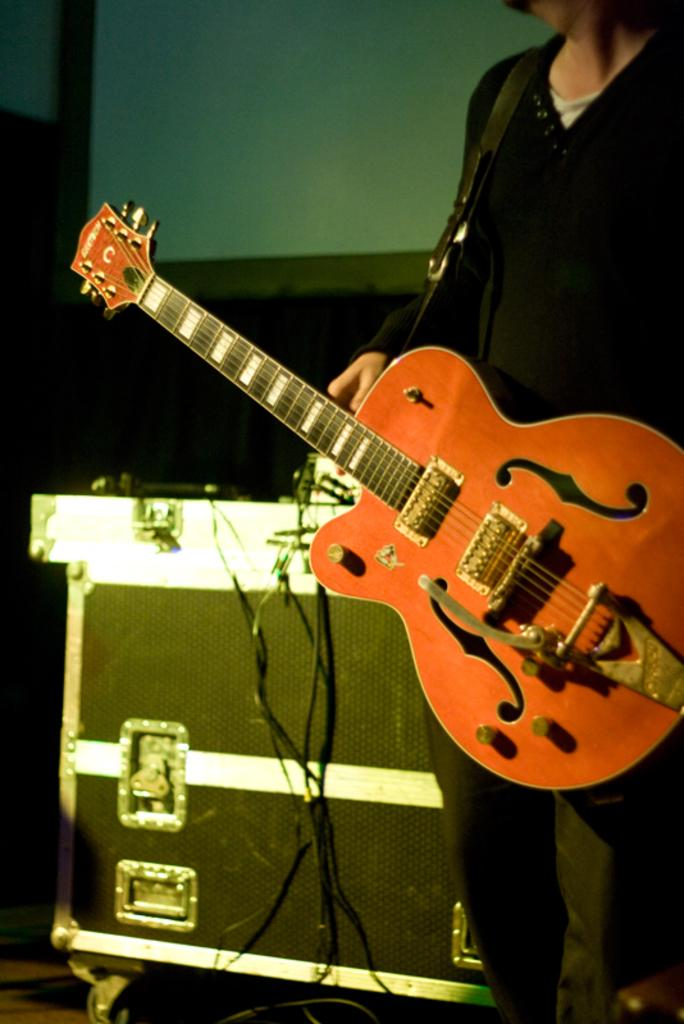What is the main subject of the image? There is a person in the image. What is the person wearing? The person is wearing a guitar. What other object can be seen in the image? There is a box in the image. How many cards are being played by the person in the image? There are no cards present in the image; the person is wearing a guitar. What type of horses can be seen in the image? There are no horses present in the image; the main subject is a person wearing a guitar. 